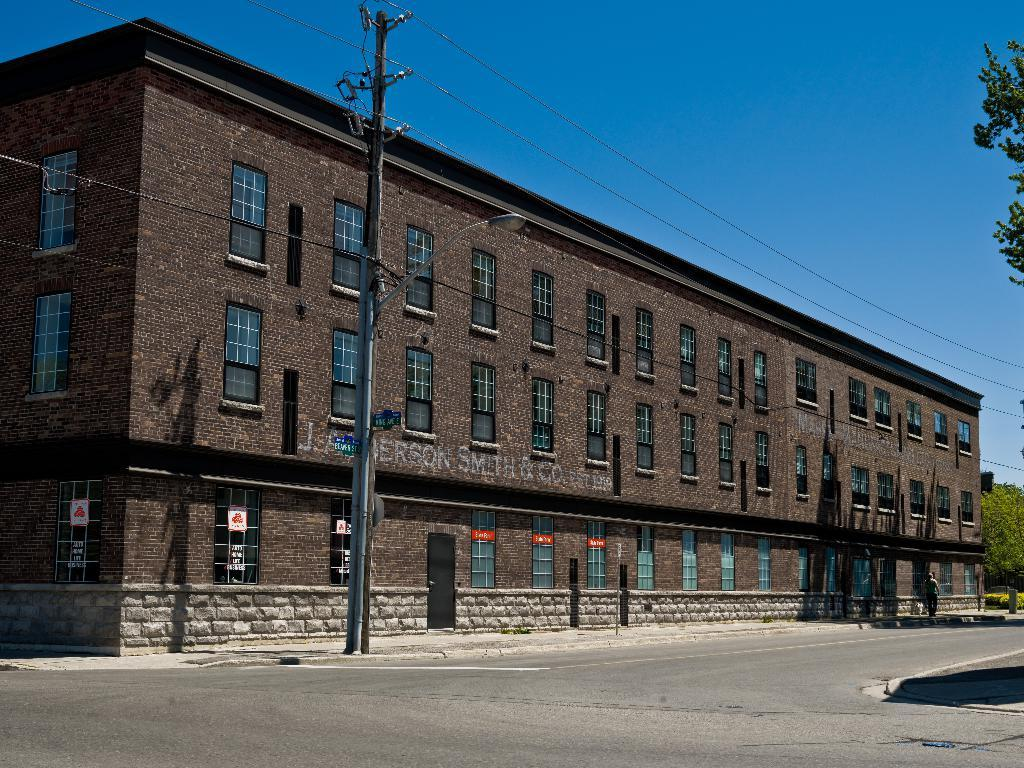What color is the building in the image? The building is in brown color. What is located at the bottom of the image? There is a road at the bottom of the image. What can be seen at the top of the image? The sky is blue in color and visible at the top of the image. How many trucks are parked on the road in the image? There are no trucks visible in the image; only the brown building, road, and blue sky are present. 